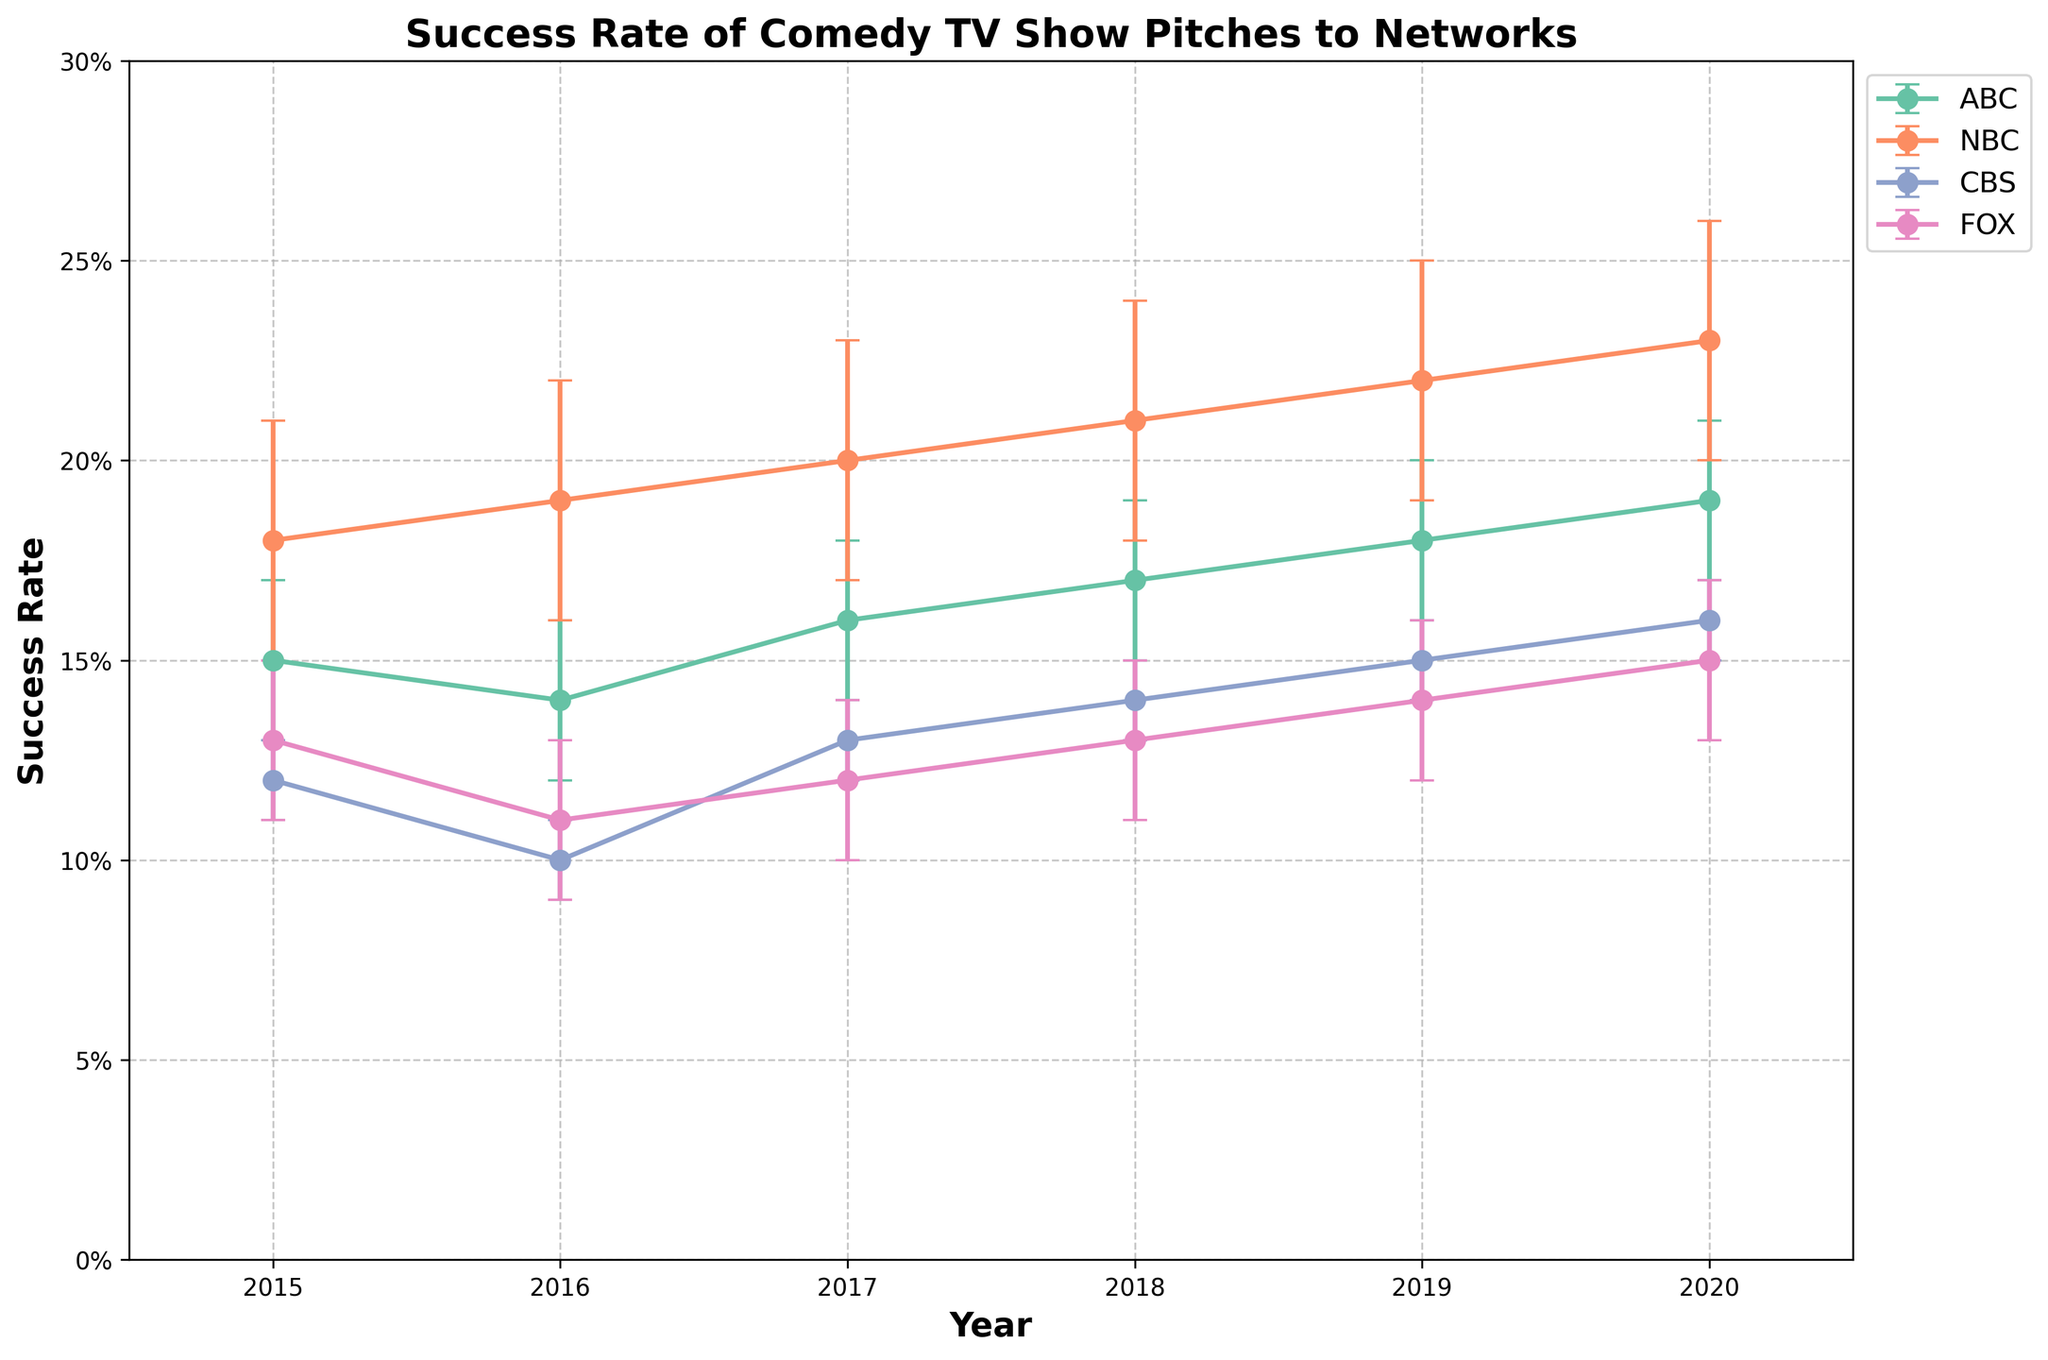What's the title of the plot? The title is displayed at the top of the plot. It states "Success Rate of Comedy TV Show Pitches to Networks".
Answer: Success Rate of Comedy TV Show Pitches to Networks How many networks are shown in the plot? The legend on the right side of the plot lists the networks. There are four networks shown: ABC, NBC, CBS, and FOX.
Answer: 4 Which network had the highest success rate in 2020? To find this, look at the error bars for 2020 and compare the success rates of the four networks. NBC's success rate is the highest in 2020.
Answer: NBC What was the success rate for CBS in 2017? Locate the 2017 data points for CBS, which are marked by a unique color and symbol in the plot. The success rate for CBS in 2017 is 0.13.
Answer: 0.13 Which network had the largest increase in success rate from 2015 to 2020? Calculate the difference in success rates for each network between 2015 and 2020 and compare them. NBC had an increase from 0.18 in 2015 to 0.23 in 2020, which is the largest increase.
Answer: NBC In which year did FOX have the lowest success rate? Examine the success rates of FOX across all years. The lowest success rate for FOX is in 2016, at 0.11.
Answer: 2016 Compare the success rates of ABC and CBS in 2019. Which one is higher? Look at the success rates for both ABC and CBS in 2019 and compare. ABC had a success rate of 0.18, while CBS had 0.15. Therefore, ABC's success rate is higher in 2019.
Answer: ABC What's the average success rate of NBC over the years? To find the average, sum the success rates of NBC from 2015 to 2020 and divide by the number of years. \( (0.18 + 0.19 + 0.20 + 0.21 + 0.22 + 0.23) / 6 = 1.23 / 6 = 0.205 \)
Answer: 0.205 What is the range of confidence intervals for FOX in 2018? Determine the confidence interval for FOX in 2018. Fox's success rate in 2018 is 0.13 with a confidence interval of 0.02, so the range is 0.11 to 0.15.
Answer: 0.11 to 0.15 